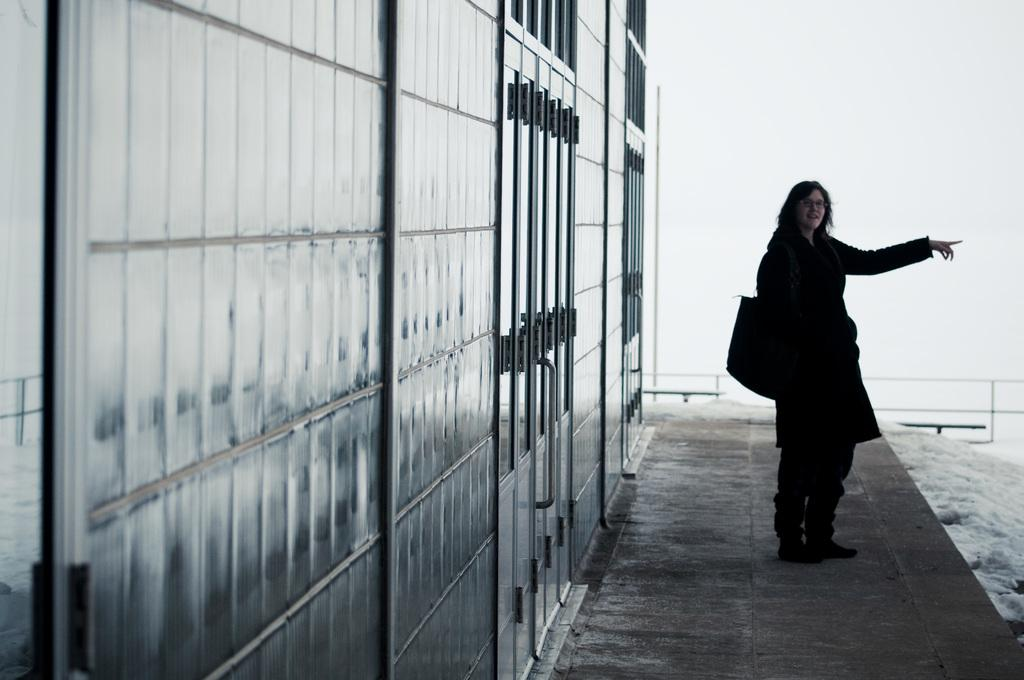What is the lady doing in the image? The lady is standing on the right side of the image. What is the lady wearing? The lady is wearing a bag. What can be seen on the left side of the image? There is a building on the left side of the image. What is visible in the background of the image? There is a wall and railings visible in the background of the image. What grade of jellyfish can be seen swimming in the background of the image? There are no jellyfish present in the image; it features a lady standing and a building in the background. 